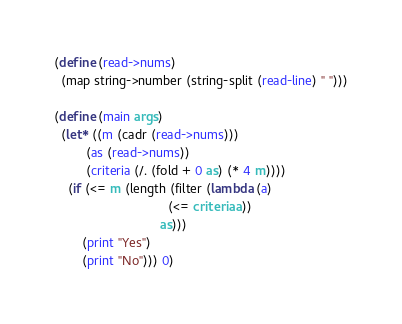<code> <loc_0><loc_0><loc_500><loc_500><_Scheme_>(define (read->nums)
  (map string->number (string-split (read-line) " ")))

(define (main args)
  (let* ((m (cadr (read->nums)))
         (as (read->nums))
         (criteria (/. (fold + 0 as) (* 4 m))))
    (if (<= m (length (filter (lambda (a)
                                (<= criteria a))
                              as)))
        (print "Yes")
        (print "No"))) 0)</code> 